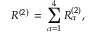<formula> <loc_0><loc_0><loc_500><loc_500>R ^ { ( 2 ) } \, = \, \sum _ { \alpha = 1 } ^ { 4 } R _ { \alpha } ^ { ( 2 ) } ,</formula> 